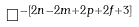Convert formula to latex. <formula><loc_0><loc_0><loc_500><loc_500>\Box ^ { - [ 2 n - 2 m + 2 p + 2 f + 3 ] }</formula> 